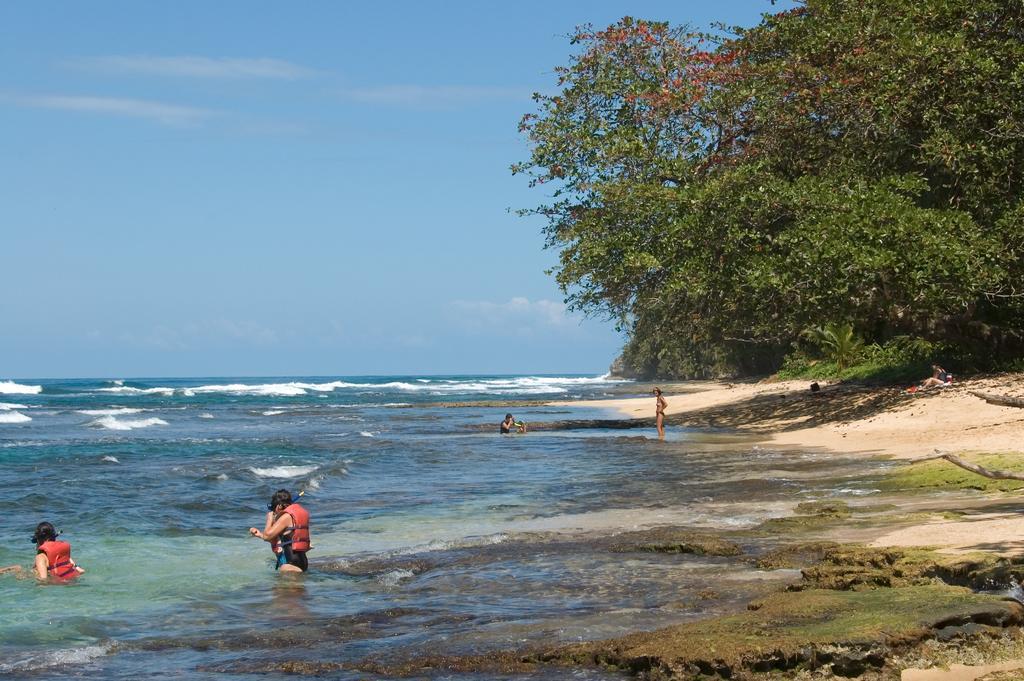How would you summarize this image in a sentence or two? There are few persons in water and there are trees in the right corner. 